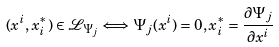<formula> <loc_0><loc_0><loc_500><loc_500>( x ^ { i } , x ^ { * } _ { i } ) \in \mathcal { L } _ { \Psi _ { j } } \Longleftrightarrow \Psi _ { j } ( x ^ { i } ) = 0 , x _ { i } ^ { * } = \frac { \partial \Psi _ { j } } { \partial x ^ { i } }</formula> 